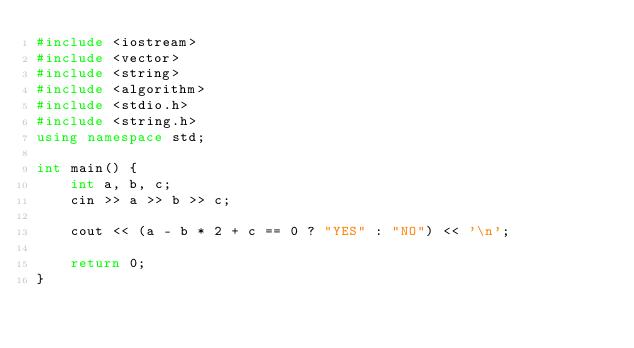<code> <loc_0><loc_0><loc_500><loc_500><_C++_>#include <iostream>
#include <vector>
#include <string>
#include <algorithm>
#include <stdio.h>
#include <string.h>
using namespace std;

int main() {
    int a, b, c;
    cin >> a >> b >> c;

    cout << (a - b * 2 + c == 0 ? "YES" : "NO") << '\n';

    return 0;
}</code> 